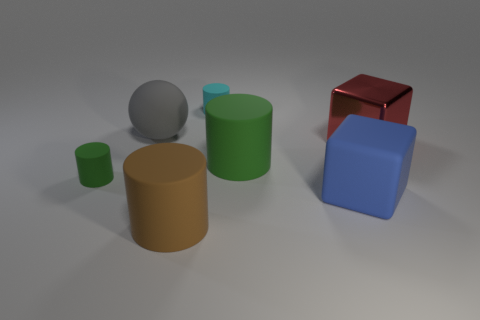Are there any other things that have the same material as the big red cube?
Your response must be concise. No. There is a tiny object that is in front of the small cyan rubber thing; what material is it?
Give a very brief answer. Rubber. There is a big green thing; is it the same shape as the small matte thing to the right of the large brown cylinder?
Your answer should be very brief. Yes. There is another shiny thing that is the same size as the blue object; what color is it?
Provide a succinct answer. Red. Is the number of big gray things right of the small green rubber thing less than the number of large things that are left of the small cyan thing?
Ensure brevity in your answer.  Yes. What shape is the small thing that is behind the green rubber cylinder right of the small matte cylinder on the right side of the large ball?
Ensure brevity in your answer.  Cylinder. There is a big matte cylinder that is behind the small green matte cylinder; is its color the same as the tiny thing on the left side of the large gray ball?
Your answer should be very brief. Yes. How many matte things are large cyan spheres or large gray things?
Your answer should be very brief. 1. There is a cube in front of the small cylinder that is on the left side of the thing that is in front of the blue rubber object; what is its color?
Your answer should be very brief. Blue. What is the color of the other large matte object that is the same shape as the big green thing?
Give a very brief answer. Brown. 